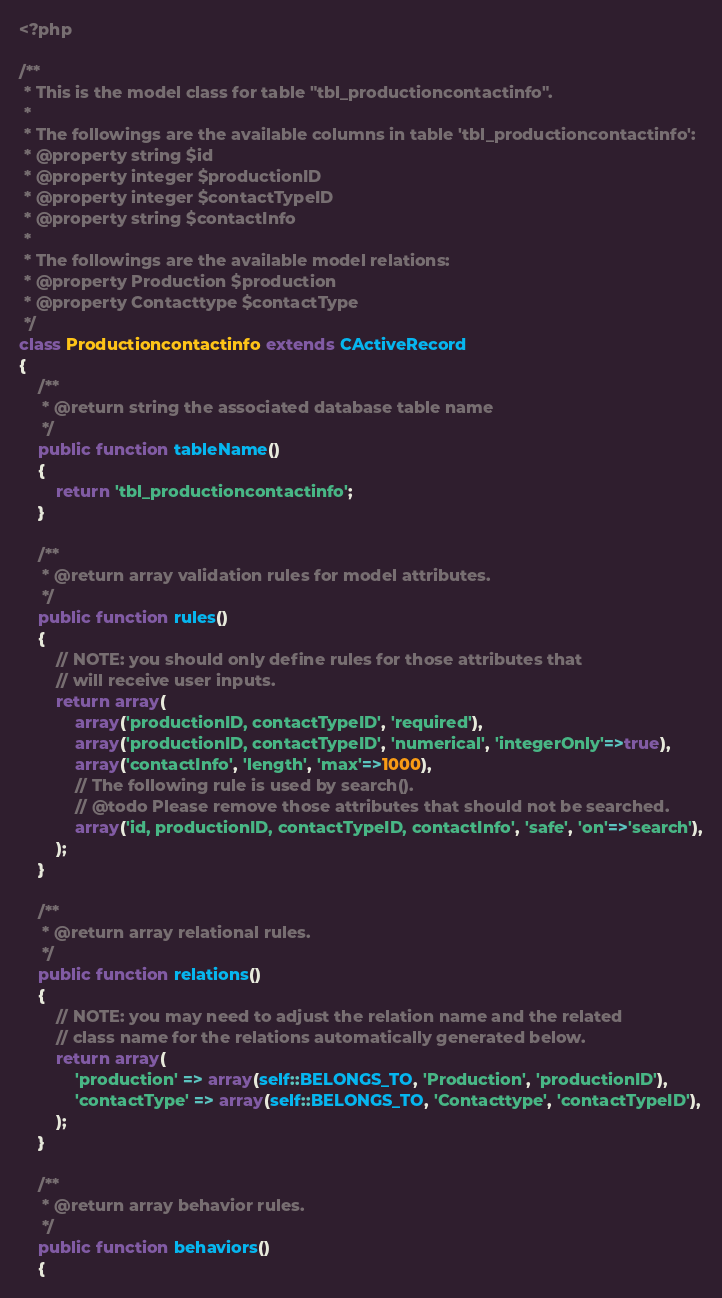<code> <loc_0><loc_0><loc_500><loc_500><_PHP_><?php

/**
 * This is the model class for table "tbl_productioncontactinfo".
 *
 * The followings are the available columns in table 'tbl_productioncontactinfo':
 * @property string $id
 * @property integer $productionID
 * @property integer $contactTypeID
 * @property string $contactInfo
 *
 * The followings are the available model relations:
 * @property Production $production
 * @property Contacttype $contactType
 */
class Productioncontactinfo extends CActiveRecord
{
	/**
	 * @return string the associated database table name
	 */
	public function tableName()
	{
		return 'tbl_productioncontactinfo';
	}

	/**
	 * @return array validation rules for model attributes.
	 */
	public function rules()
	{
		// NOTE: you should only define rules for those attributes that
		// will receive user inputs.
		return array(
			array('productionID, contactTypeID', 'required'),
			array('productionID, contactTypeID', 'numerical', 'integerOnly'=>true),
			array('contactInfo', 'length', 'max'=>1000),
			// The following rule is used by search().
			// @todo Please remove those attributes that should not be searched.
			array('id, productionID, contactTypeID, contactInfo', 'safe', 'on'=>'search'),
		);
	}

	/**
	 * @return array relational rules.
	 */
	public function relations()
	{
		// NOTE: you may need to adjust the relation name and the related
		// class name for the relations automatically generated below.
		return array(
			'production' => array(self::BELONGS_TO, 'Production', 'productionID'),
			'contactType' => array(self::BELONGS_TO, 'Contacttype', 'contactTypeID'),
		);
	}
	
	/**
	 * @return array behavior rules.
	 */
	public function behaviors()
    {</code> 